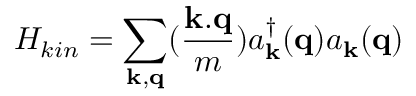<formula> <loc_0><loc_0><loc_500><loc_500>H _ { k i n } = \sum _ { { k } , { q } } ( \frac { k . q } { m } ) a _ { k } ^ { \dagger } ( { q } ) a _ { k } ( { q } )</formula> 